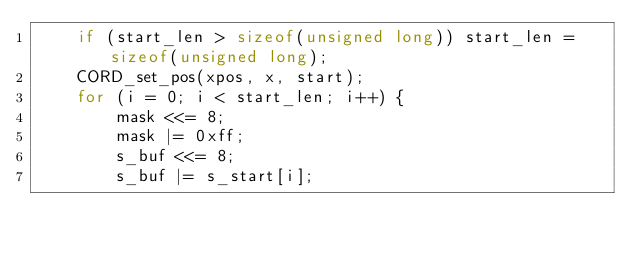Convert code to text. <code><loc_0><loc_0><loc_500><loc_500><_C_>    if (start_len > sizeof(unsigned long)) start_len = sizeof(unsigned long);
    CORD_set_pos(xpos, x, start);
    for (i = 0; i < start_len; i++) {
        mask <<= 8;
        mask |= 0xff;
        s_buf <<= 8;
        s_buf |= s_start[i];</code> 